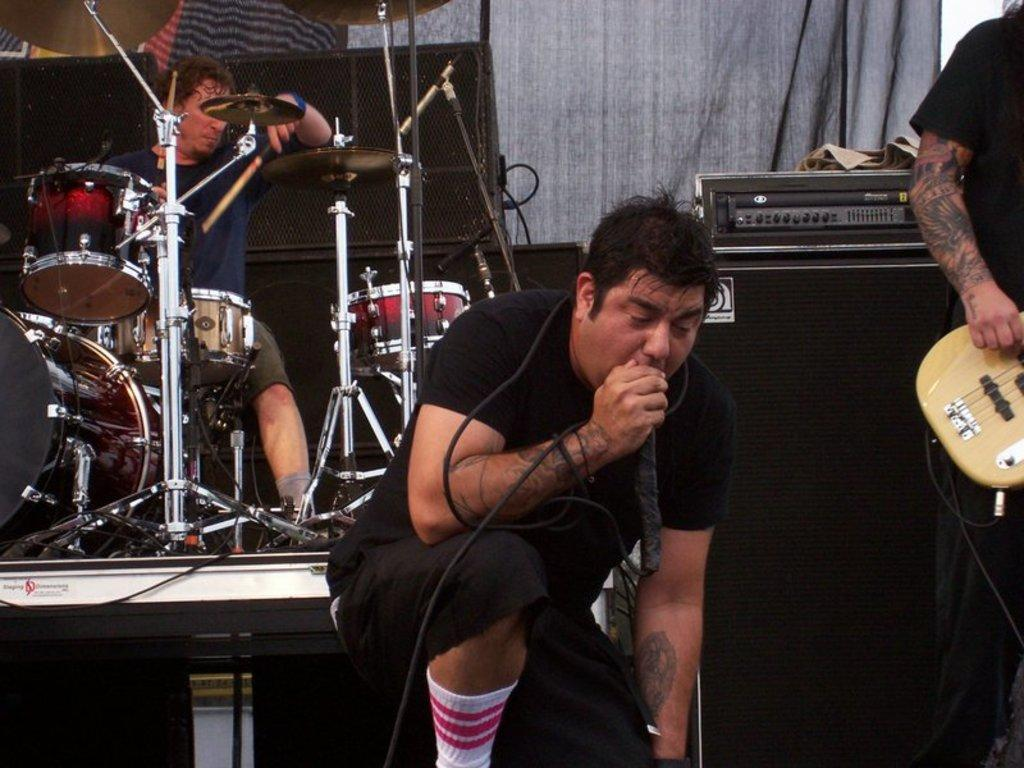How many people are in the image? There are two persons in the image. What are the two persons doing in the image? One person is sitting and playing drums, while another person is sitting and singing into a microphone. Is there a third person in the image? Yes, there is a third person standing and playing a guitar. What type of eggnog is being served in the image? There is no eggnog present in the image. Is there any smoke visible in the image? No, there is no smoke visible in the image. 